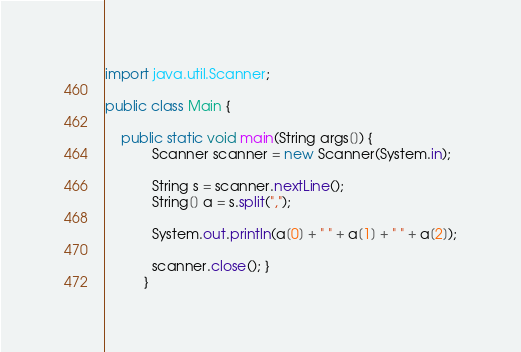Convert code to text. <code><loc_0><loc_0><loc_500><loc_500><_Java_>import java.util.Scanner;

public class Main {
	  
	public static void main(String args[]) {
		    Scanner scanner = new Scanner(System.in);
		    
		    String s = scanner.nextLine();
		    String[] a = s.split(",");
		    
		    System.out.println(a[0] + " " + a[1] + " " + a[2]);
		    
		    scanner.close(); }
		  }</code> 